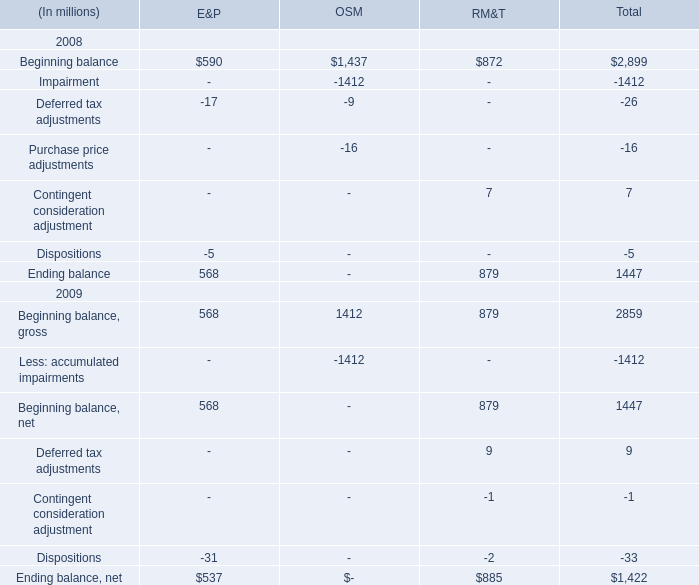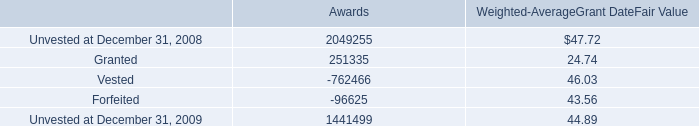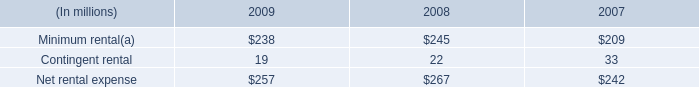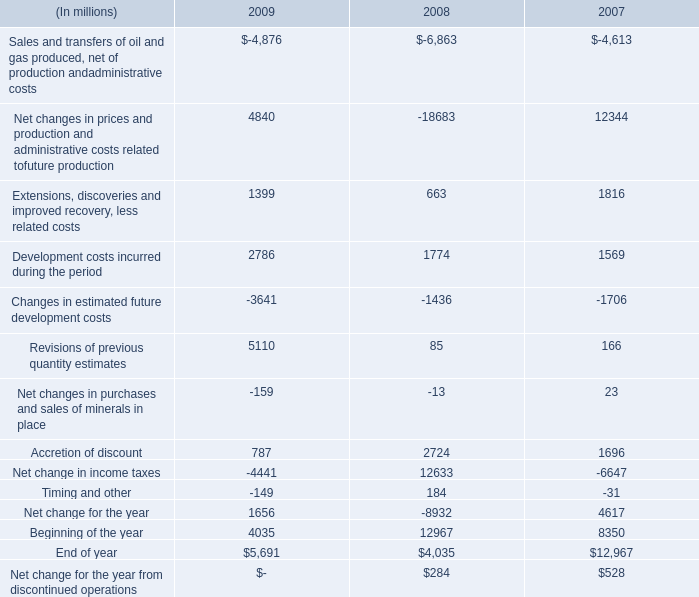Which year is Beginning balance for RM&T greater than 878 ? 
Answer: 2009. What is the ratio of Beginning balance for RM&T to the total in 2008? 
Computations: (872 / 879)
Answer: 0.99204. 